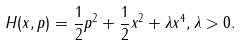Convert formula to latex. <formula><loc_0><loc_0><loc_500><loc_500>H ( x , p ) = \frac { 1 } { 2 } p ^ { 2 } + \frac { 1 } { 2 } x ^ { 2 } + \lambda x ^ { 4 } , \lambda > 0 .</formula> 